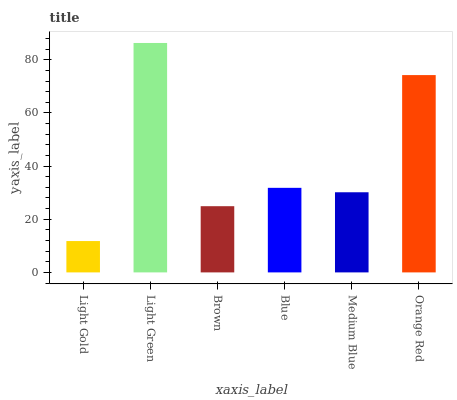Is Brown the minimum?
Answer yes or no. No. Is Brown the maximum?
Answer yes or no. No. Is Light Green greater than Brown?
Answer yes or no. Yes. Is Brown less than Light Green?
Answer yes or no. Yes. Is Brown greater than Light Green?
Answer yes or no. No. Is Light Green less than Brown?
Answer yes or no. No. Is Blue the high median?
Answer yes or no. Yes. Is Medium Blue the low median?
Answer yes or no. Yes. Is Orange Red the high median?
Answer yes or no. No. Is Blue the low median?
Answer yes or no. No. 